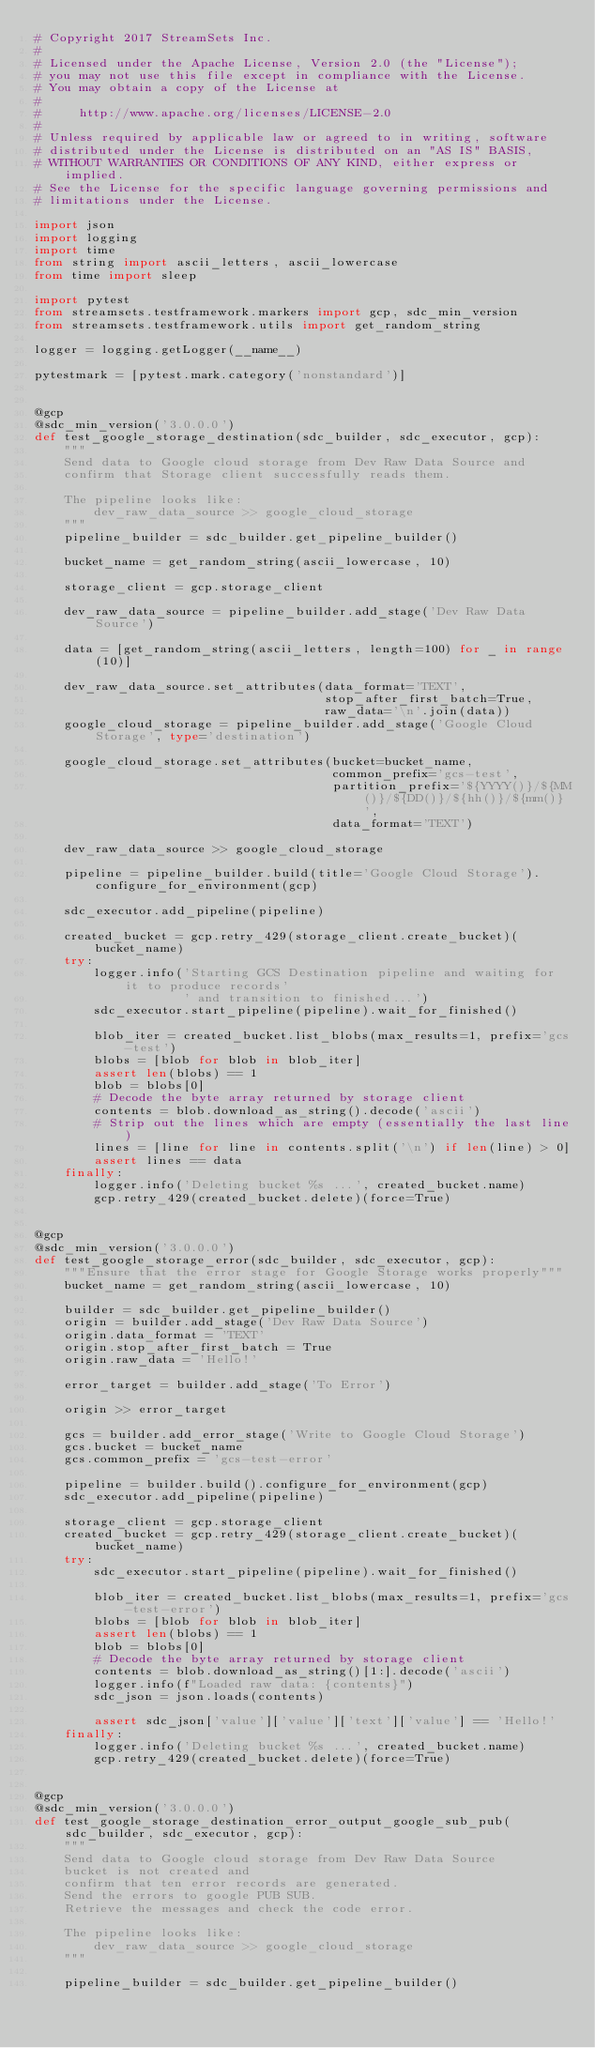Convert code to text. <code><loc_0><loc_0><loc_500><loc_500><_Python_># Copyright 2017 StreamSets Inc.
#
# Licensed under the Apache License, Version 2.0 (the "License");
# you may not use this file except in compliance with the License.
# You may obtain a copy of the License at
#
#     http://www.apache.org/licenses/LICENSE-2.0
#
# Unless required by applicable law or agreed to in writing, software
# distributed under the License is distributed on an "AS IS" BASIS,
# WITHOUT WARRANTIES OR CONDITIONS OF ANY KIND, either express or implied.
# See the License for the specific language governing permissions and
# limitations under the License.

import json
import logging
import time
from string import ascii_letters, ascii_lowercase
from time import sleep

import pytest
from streamsets.testframework.markers import gcp, sdc_min_version
from streamsets.testframework.utils import get_random_string

logger = logging.getLogger(__name__)

pytestmark = [pytest.mark.category('nonstandard')]


@gcp
@sdc_min_version('3.0.0.0')
def test_google_storage_destination(sdc_builder, sdc_executor, gcp):
    """
    Send data to Google cloud storage from Dev Raw Data Source and
    confirm that Storage client successfully reads them.

    The pipeline looks like:
        dev_raw_data_source >> google_cloud_storage
    """
    pipeline_builder = sdc_builder.get_pipeline_builder()

    bucket_name = get_random_string(ascii_lowercase, 10)

    storage_client = gcp.storage_client

    dev_raw_data_source = pipeline_builder.add_stage('Dev Raw Data Source')

    data = [get_random_string(ascii_letters, length=100) for _ in range(10)]

    dev_raw_data_source.set_attributes(data_format='TEXT',
                                       stop_after_first_batch=True,
                                       raw_data='\n'.join(data))
    google_cloud_storage = pipeline_builder.add_stage('Google Cloud Storage', type='destination')

    google_cloud_storage.set_attributes(bucket=bucket_name,
                                        common_prefix='gcs-test',
                                        partition_prefix='${YYYY()}/${MM()}/${DD()}/${hh()}/${mm()}',
                                        data_format='TEXT')

    dev_raw_data_source >> google_cloud_storage

    pipeline = pipeline_builder.build(title='Google Cloud Storage').configure_for_environment(gcp)

    sdc_executor.add_pipeline(pipeline)

    created_bucket = gcp.retry_429(storage_client.create_bucket)(bucket_name)
    try:
        logger.info('Starting GCS Destination pipeline and waiting for it to produce records'
                    ' and transition to finished...')
        sdc_executor.start_pipeline(pipeline).wait_for_finished()

        blob_iter = created_bucket.list_blobs(max_results=1, prefix='gcs-test')
        blobs = [blob for blob in blob_iter]
        assert len(blobs) == 1
        blob = blobs[0]
        # Decode the byte array returned by storage client
        contents = blob.download_as_string().decode('ascii')
        # Strip out the lines which are empty (essentially the last line)
        lines = [line for line in contents.split('\n') if len(line) > 0]
        assert lines == data
    finally:
        logger.info('Deleting bucket %s ...', created_bucket.name)
        gcp.retry_429(created_bucket.delete)(force=True)


@gcp
@sdc_min_version('3.0.0.0')
def test_google_storage_error(sdc_builder, sdc_executor, gcp):
    """Ensure that the error stage for Google Storage works properly"""
    bucket_name = get_random_string(ascii_lowercase, 10)

    builder = sdc_builder.get_pipeline_builder()
    origin = builder.add_stage('Dev Raw Data Source')
    origin.data_format = 'TEXT'
    origin.stop_after_first_batch = True
    origin.raw_data = 'Hello!'

    error_target = builder.add_stage('To Error')

    origin >> error_target

    gcs = builder.add_error_stage('Write to Google Cloud Storage')
    gcs.bucket = bucket_name
    gcs.common_prefix = 'gcs-test-error'

    pipeline = builder.build().configure_for_environment(gcp)
    sdc_executor.add_pipeline(pipeline)

    storage_client = gcp.storage_client
    created_bucket = gcp.retry_429(storage_client.create_bucket)(bucket_name)
    try:
        sdc_executor.start_pipeline(pipeline).wait_for_finished()

        blob_iter = created_bucket.list_blobs(max_results=1, prefix='gcs-test-error')
        blobs = [blob for blob in blob_iter]
        assert len(blobs) == 1
        blob = blobs[0]
        # Decode the byte array returned by storage client
        contents = blob.download_as_string()[1:].decode('ascii')
        logger.info(f"Loaded raw data: {contents}")
        sdc_json = json.loads(contents)

        assert sdc_json['value']['value']['text']['value'] == 'Hello!'
    finally:
        logger.info('Deleting bucket %s ...', created_bucket.name)
        gcp.retry_429(created_bucket.delete)(force=True)


@gcp
@sdc_min_version('3.0.0.0')
def test_google_storage_destination_error_output_google_sub_pub(sdc_builder, sdc_executor, gcp):
    """
    Send data to Google cloud storage from Dev Raw Data Source
    bucket is not created and
    confirm that ten error records are generated.
    Send the errors to google PUB SUB.
    Retrieve the messages and check the code error.

    The pipeline looks like:
        dev_raw_data_source >> google_cloud_storage
    """

    pipeline_builder = sdc_builder.get_pipeline_builder()
</code> 